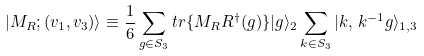<formula> <loc_0><loc_0><loc_500><loc_500>| M _ { R } ; ( v _ { 1 } , v _ { 3 } ) \rangle \equiv \frac { 1 } { 6 } \sum _ { g \in S _ { 3 } } t r \{ M _ { R } R ^ { \dagger } ( g ) \} | g \rangle _ { 2 } \sum _ { k \in S _ { 3 } } | k , \, k ^ { - 1 } g \rangle _ { 1 , 3 }</formula> 